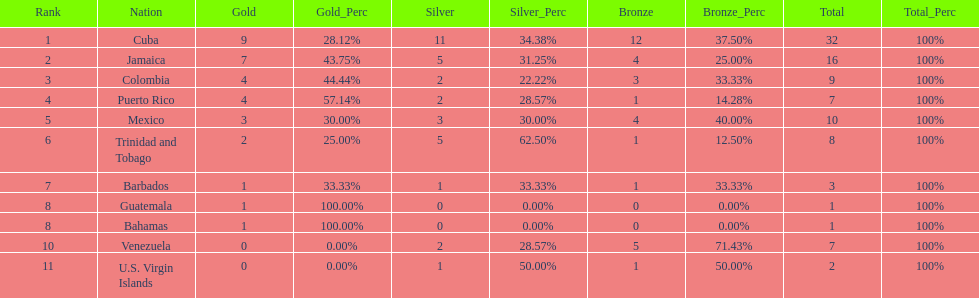Which team had four gold models and one bronze medal? Puerto Rico. 